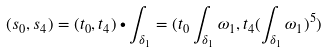<formula> <loc_0><loc_0><loc_500><loc_500>( s _ { 0 } , s _ { 4 } ) = ( t _ { 0 } , t _ { 4 } ) \bullet \int _ { \delta _ { 1 } } = ( t _ { 0 } \int _ { \delta _ { 1 } } \omega _ { 1 } , t _ { 4 } ( \int _ { \delta _ { 1 } } \omega _ { 1 } ) ^ { 5 } )</formula> 